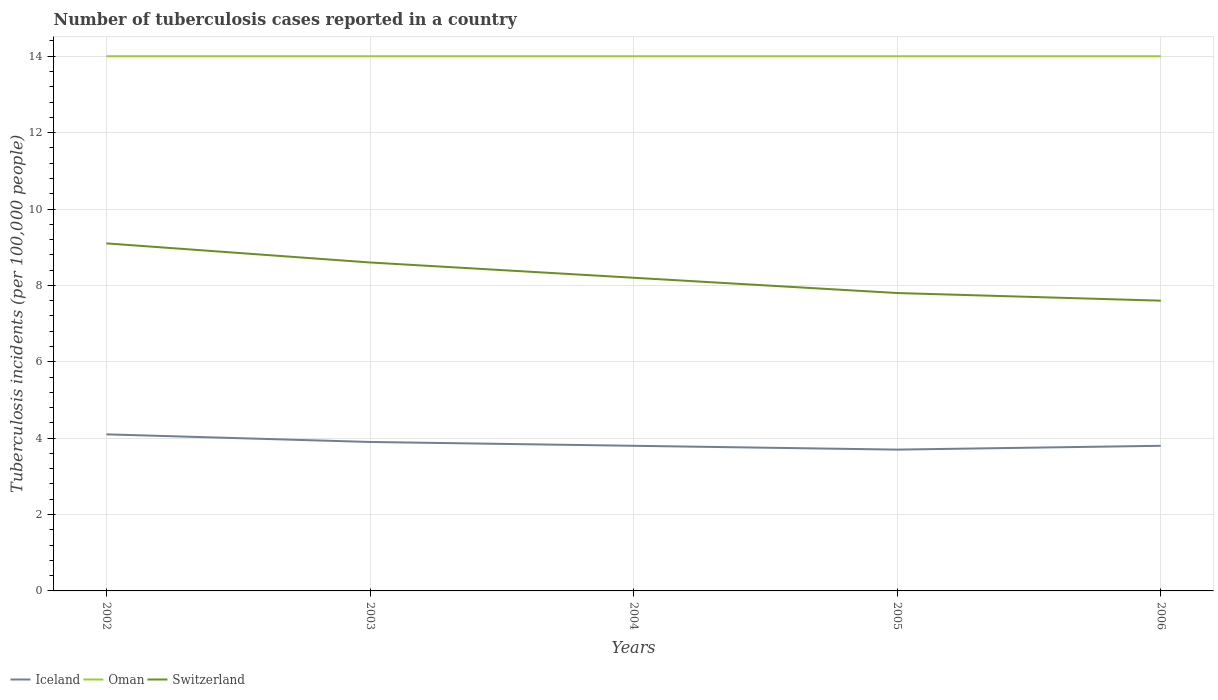In which year was the number of tuberculosis cases reported in in Switzerland maximum?
Your response must be concise. 2006. What is the total number of tuberculosis cases reported in in Iceland in the graph?
Keep it short and to the point. 0.1. What is the difference between the highest and the second highest number of tuberculosis cases reported in in Iceland?
Your response must be concise. 0.4. What is the difference between the highest and the lowest number of tuberculosis cases reported in in Oman?
Provide a short and direct response. 0. Is the number of tuberculosis cases reported in in Switzerland strictly greater than the number of tuberculosis cases reported in in Iceland over the years?
Make the answer very short. No. How many years are there in the graph?
Offer a terse response. 5. What is the difference between two consecutive major ticks on the Y-axis?
Give a very brief answer. 2. Are the values on the major ticks of Y-axis written in scientific E-notation?
Make the answer very short. No. Where does the legend appear in the graph?
Your answer should be compact. Bottom left. How are the legend labels stacked?
Make the answer very short. Horizontal. What is the title of the graph?
Ensure brevity in your answer.  Number of tuberculosis cases reported in a country. Does "Turkey" appear as one of the legend labels in the graph?
Provide a succinct answer. No. What is the label or title of the X-axis?
Offer a terse response. Years. What is the label or title of the Y-axis?
Give a very brief answer. Tuberculosis incidents (per 100,0 people). What is the Tuberculosis incidents (per 100,000 people) of Iceland in 2002?
Keep it short and to the point. 4.1. What is the Tuberculosis incidents (per 100,000 people) in Oman in 2002?
Offer a terse response. 14. What is the Tuberculosis incidents (per 100,000 people) of Switzerland in 2002?
Keep it short and to the point. 9.1. What is the Tuberculosis incidents (per 100,000 people) in Iceland in 2003?
Provide a succinct answer. 3.9. What is the Tuberculosis incidents (per 100,000 people) in Iceland in 2004?
Offer a terse response. 3.8. What is the Tuberculosis incidents (per 100,000 people) in Oman in 2004?
Keep it short and to the point. 14. What is the Tuberculosis incidents (per 100,000 people) in Switzerland in 2004?
Offer a terse response. 8.2. What is the Tuberculosis incidents (per 100,000 people) in Iceland in 2005?
Offer a very short reply. 3.7. What is the Tuberculosis incidents (per 100,000 people) of Switzerland in 2005?
Offer a terse response. 7.8. What is the Tuberculosis incidents (per 100,000 people) in Iceland in 2006?
Ensure brevity in your answer.  3.8. What is the Tuberculosis incidents (per 100,000 people) in Oman in 2006?
Your answer should be very brief. 14. What is the Tuberculosis incidents (per 100,000 people) of Switzerland in 2006?
Your answer should be very brief. 7.6. Across all years, what is the maximum Tuberculosis incidents (per 100,000 people) in Switzerland?
Give a very brief answer. 9.1. Across all years, what is the minimum Tuberculosis incidents (per 100,000 people) in Iceland?
Offer a very short reply. 3.7. What is the total Tuberculosis incidents (per 100,000 people) in Iceland in the graph?
Your answer should be compact. 19.3. What is the total Tuberculosis incidents (per 100,000 people) in Oman in the graph?
Make the answer very short. 70. What is the total Tuberculosis incidents (per 100,000 people) in Switzerland in the graph?
Your response must be concise. 41.3. What is the difference between the Tuberculosis incidents (per 100,000 people) of Switzerland in 2002 and that in 2003?
Ensure brevity in your answer.  0.5. What is the difference between the Tuberculosis incidents (per 100,000 people) in Oman in 2002 and that in 2004?
Your answer should be compact. 0. What is the difference between the Tuberculosis incidents (per 100,000 people) of Oman in 2002 and that in 2005?
Your response must be concise. 0. What is the difference between the Tuberculosis incidents (per 100,000 people) of Switzerland in 2002 and that in 2005?
Your response must be concise. 1.3. What is the difference between the Tuberculosis incidents (per 100,000 people) of Iceland in 2002 and that in 2006?
Your answer should be very brief. 0.3. What is the difference between the Tuberculosis incidents (per 100,000 people) of Switzerland in 2002 and that in 2006?
Your answer should be compact. 1.5. What is the difference between the Tuberculosis incidents (per 100,000 people) of Iceland in 2003 and that in 2004?
Provide a short and direct response. 0.1. What is the difference between the Tuberculosis incidents (per 100,000 people) of Switzerland in 2003 and that in 2004?
Give a very brief answer. 0.4. What is the difference between the Tuberculosis incidents (per 100,000 people) of Oman in 2003 and that in 2006?
Your answer should be compact. 0. What is the difference between the Tuberculosis incidents (per 100,000 people) of Switzerland in 2003 and that in 2006?
Ensure brevity in your answer.  1. What is the difference between the Tuberculosis incidents (per 100,000 people) of Oman in 2004 and that in 2005?
Ensure brevity in your answer.  0. What is the difference between the Tuberculosis incidents (per 100,000 people) of Switzerland in 2004 and that in 2005?
Make the answer very short. 0.4. What is the difference between the Tuberculosis incidents (per 100,000 people) in Iceland in 2005 and that in 2006?
Provide a succinct answer. -0.1. What is the difference between the Tuberculosis incidents (per 100,000 people) in Iceland in 2002 and the Tuberculosis incidents (per 100,000 people) in Oman in 2003?
Offer a terse response. -9.9. What is the difference between the Tuberculosis incidents (per 100,000 people) in Iceland in 2002 and the Tuberculosis incidents (per 100,000 people) in Switzerland in 2003?
Your response must be concise. -4.5. What is the difference between the Tuberculosis incidents (per 100,000 people) of Iceland in 2002 and the Tuberculosis incidents (per 100,000 people) of Oman in 2004?
Provide a succinct answer. -9.9. What is the difference between the Tuberculosis incidents (per 100,000 people) of Iceland in 2002 and the Tuberculosis incidents (per 100,000 people) of Oman in 2005?
Make the answer very short. -9.9. What is the difference between the Tuberculosis incidents (per 100,000 people) in Iceland in 2002 and the Tuberculosis incidents (per 100,000 people) in Switzerland in 2005?
Offer a terse response. -3.7. What is the difference between the Tuberculosis incidents (per 100,000 people) of Oman in 2002 and the Tuberculosis incidents (per 100,000 people) of Switzerland in 2005?
Make the answer very short. 6.2. What is the difference between the Tuberculosis incidents (per 100,000 people) in Iceland in 2003 and the Tuberculosis incidents (per 100,000 people) in Oman in 2004?
Your answer should be compact. -10.1. What is the difference between the Tuberculosis incidents (per 100,000 people) of Iceland in 2003 and the Tuberculosis incidents (per 100,000 people) of Oman in 2005?
Your response must be concise. -10.1. What is the difference between the Tuberculosis incidents (per 100,000 people) of Iceland in 2003 and the Tuberculosis incidents (per 100,000 people) of Switzerland in 2005?
Your answer should be very brief. -3.9. What is the difference between the Tuberculosis incidents (per 100,000 people) of Iceland in 2003 and the Tuberculosis incidents (per 100,000 people) of Oman in 2006?
Offer a terse response. -10.1. What is the difference between the Tuberculosis incidents (per 100,000 people) of Oman in 2003 and the Tuberculosis incidents (per 100,000 people) of Switzerland in 2006?
Offer a terse response. 6.4. What is the difference between the Tuberculosis incidents (per 100,000 people) in Iceland in 2004 and the Tuberculosis incidents (per 100,000 people) in Switzerland in 2005?
Offer a terse response. -4. What is the difference between the Tuberculosis incidents (per 100,000 people) of Iceland in 2005 and the Tuberculosis incidents (per 100,000 people) of Switzerland in 2006?
Make the answer very short. -3.9. What is the difference between the Tuberculosis incidents (per 100,000 people) in Oman in 2005 and the Tuberculosis incidents (per 100,000 people) in Switzerland in 2006?
Provide a succinct answer. 6.4. What is the average Tuberculosis incidents (per 100,000 people) in Iceland per year?
Your response must be concise. 3.86. What is the average Tuberculosis incidents (per 100,000 people) of Switzerland per year?
Provide a short and direct response. 8.26. In the year 2002, what is the difference between the Tuberculosis incidents (per 100,000 people) of Oman and Tuberculosis incidents (per 100,000 people) of Switzerland?
Ensure brevity in your answer.  4.9. In the year 2003, what is the difference between the Tuberculosis incidents (per 100,000 people) of Iceland and Tuberculosis incidents (per 100,000 people) of Oman?
Ensure brevity in your answer.  -10.1. In the year 2003, what is the difference between the Tuberculosis incidents (per 100,000 people) in Iceland and Tuberculosis incidents (per 100,000 people) in Switzerland?
Offer a terse response. -4.7. In the year 2003, what is the difference between the Tuberculosis incidents (per 100,000 people) of Oman and Tuberculosis incidents (per 100,000 people) of Switzerland?
Your answer should be compact. 5.4. In the year 2004, what is the difference between the Tuberculosis incidents (per 100,000 people) in Iceland and Tuberculosis incidents (per 100,000 people) in Oman?
Give a very brief answer. -10.2. In the year 2004, what is the difference between the Tuberculosis incidents (per 100,000 people) of Oman and Tuberculosis incidents (per 100,000 people) of Switzerland?
Make the answer very short. 5.8. In the year 2005, what is the difference between the Tuberculosis incidents (per 100,000 people) in Iceland and Tuberculosis incidents (per 100,000 people) in Oman?
Keep it short and to the point. -10.3. In the year 2005, what is the difference between the Tuberculosis incidents (per 100,000 people) of Iceland and Tuberculosis incidents (per 100,000 people) of Switzerland?
Provide a short and direct response. -4.1. In the year 2005, what is the difference between the Tuberculosis incidents (per 100,000 people) of Oman and Tuberculosis incidents (per 100,000 people) of Switzerland?
Your answer should be compact. 6.2. In the year 2006, what is the difference between the Tuberculosis incidents (per 100,000 people) in Iceland and Tuberculosis incidents (per 100,000 people) in Oman?
Keep it short and to the point. -10.2. In the year 2006, what is the difference between the Tuberculosis incidents (per 100,000 people) of Iceland and Tuberculosis incidents (per 100,000 people) of Switzerland?
Give a very brief answer. -3.8. In the year 2006, what is the difference between the Tuberculosis incidents (per 100,000 people) of Oman and Tuberculosis incidents (per 100,000 people) of Switzerland?
Give a very brief answer. 6.4. What is the ratio of the Tuberculosis incidents (per 100,000 people) in Iceland in 2002 to that in 2003?
Make the answer very short. 1.05. What is the ratio of the Tuberculosis incidents (per 100,000 people) in Switzerland in 2002 to that in 2003?
Your response must be concise. 1.06. What is the ratio of the Tuberculosis incidents (per 100,000 people) of Iceland in 2002 to that in 2004?
Make the answer very short. 1.08. What is the ratio of the Tuberculosis incidents (per 100,000 people) of Switzerland in 2002 to that in 2004?
Offer a very short reply. 1.11. What is the ratio of the Tuberculosis incidents (per 100,000 people) of Iceland in 2002 to that in 2005?
Give a very brief answer. 1.11. What is the ratio of the Tuberculosis incidents (per 100,000 people) in Switzerland in 2002 to that in 2005?
Offer a very short reply. 1.17. What is the ratio of the Tuberculosis incidents (per 100,000 people) of Iceland in 2002 to that in 2006?
Keep it short and to the point. 1.08. What is the ratio of the Tuberculosis incidents (per 100,000 people) of Oman in 2002 to that in 2006?
Offer a very short reply. 1. What is the ratio of the Tuberculosis incidents (per 100,000 people) of Switzerland in 2002 to that in 2006?
Offer a terse response. 1.2. What is the ratio of the Tuberculosis incidents (per 100,000 people) of Iceland in 2003 to that in 2004?
Offer a very short reply. 1.03. What is the ratio of the Tuberculosis incidents (per 100,000 people) of Switzerland in 2003 to that in 2004?
Provide a succinct answer. 1.05. What is the ratio of the Tuberculosis incidents (per 100,000 people) of Iceland in 2003 to that in 2005?
Offer a terse response. 1.05. What is the ratio of the Tuberculosis incidents (per 100,000 people) of Oman in 2003 to that in 2005?
Provide a succinct answer. 1. What is the ratio of the Tuberculosis incidents (per 100,000 people) in Switzerland in 2003 to that in 2005?
Keep it short and to the point. 1.1. What is the ratio of the Tuberculosis incidents (per 100,000 people) of Iceland in 2003 to that in 2006?
Keep it short and to the point. 1.03. What is the ratio of the Tuberculosis incidents (per 100,000 people) of Oman in 2003 to that in 2006?
Keep it short and to the point. 1. What is the ratio of the Tuberculosis incidents (per 100,000 people) in Switzerland in 2003 to that in 2006?
Give a very brief answer. 1.13. What is the ratio of the Tuberculosis incidents (per 100,000 people) of Oman in 2004 to that in 2005?
Offer a very short reply. 1. What is the ratio of the Tuberculosis incidents (per 100,000 people) of Switzerland in 2004 to that in 2005?
Keep it short and to the point. 1.05. What is the ratio of the Tuberculosis incidents (per 100,000 people) in Oman in 2004 to that in 2006?
Provide a short and direct response. 1. What is the ratio of the Tuberculosis incidents (per 100,000 people) in Switzerland in 2004 to that in 2006?
Your answer should be compact. 1.08. What is the ratio of the Tuberculosis incidents (per 100,000 people) in Iceland in 2005 to that in 2006?
Make the answer very short. 0.97. What is the ratio of the Tuberculosis incidents (per 100,000 people) of Switzerland in 2005 to that in 2006?
Provide a succinct answer. 1.03. What is the difference between the highest and the second highest Tuberculosis incidents (per 100,000 people) in Iceland?
Offer a terse response. 0.2. What is the difference between the highest and the second highest Tuberculosis incidents (per 100,000 people) of Oman?
Ensure brevity in your answer.  0. What is the difference between the highest and the second highest Tuberculosis incidents (per 100,000 people) in Switzerland?
Keep it short and to the point. 0.5. What is the difference between the highest and the lowest Tuberculosis incidents (per 100,000 people) of Iceland?
Offer a very short reply. 0.4. What is the difference between the highest and the lowest Tuberculosis incidents (per 100,000 people) in Switzerland?
Ensure brevity in your answer.  1.5. 